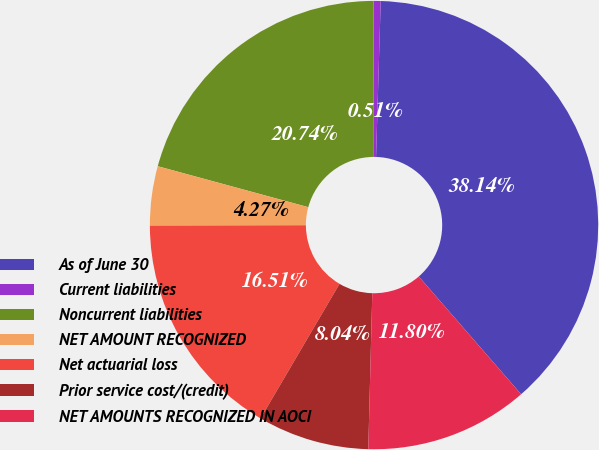Convert chart. <chart><loc_0><loc_0><loc_500><loc_500><pie_chart><fcel>As of June 30<fcel>Current liabilities<fcel>Noncurrent liabilities<fcel>NET AMOUNT RECOGNIZED<fcel>Net actuarial loss<fcel>Prior service cost/(credit)<fcel>NET AMOUNTS RECOGNIZED IN AOCI<nl><fcel>38.14%<fcel>0.51%<fcel>20.74%<fcel>4.27%<fcel>16.51%<fcel>8.04%<fcel>11.8%<nl></chart> 